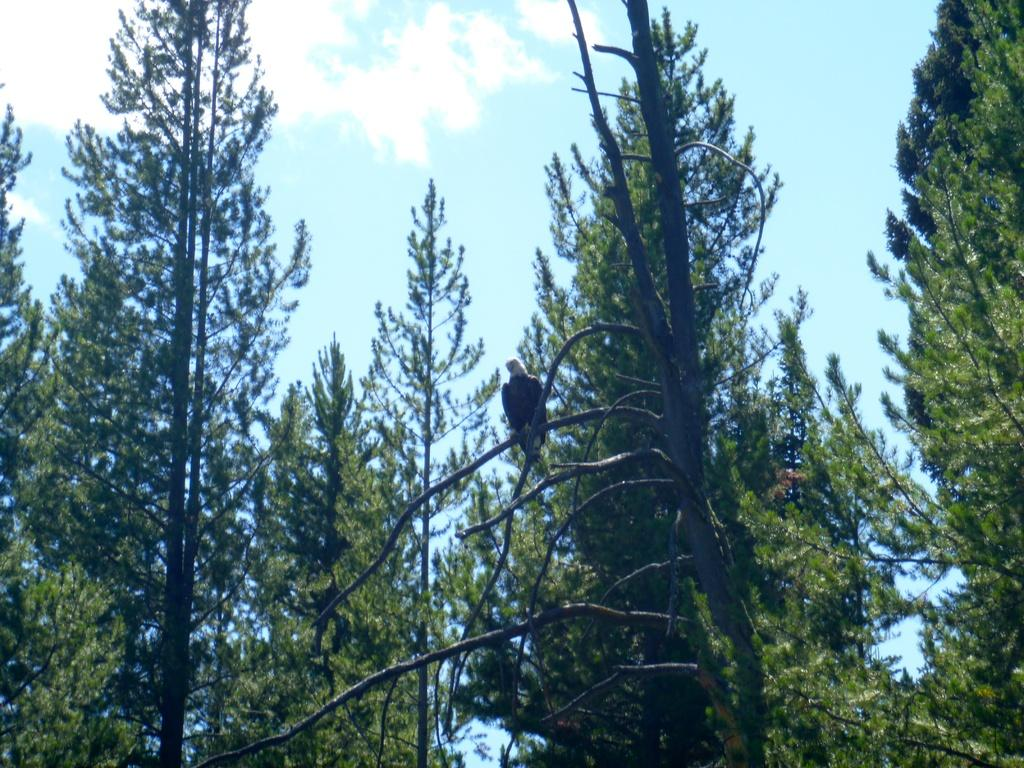What type of vegetation is visible in the image? There are many tall trees in the image. Can you describe the bird in the image? There is a bird standing on a branch in the image. What can be seen in the sky in the image? There are clouds in the sky in the image. What type of card is being used to build the tent in the image? There is no card or tent present in the image; it features tall trees and a bird on a branch. 